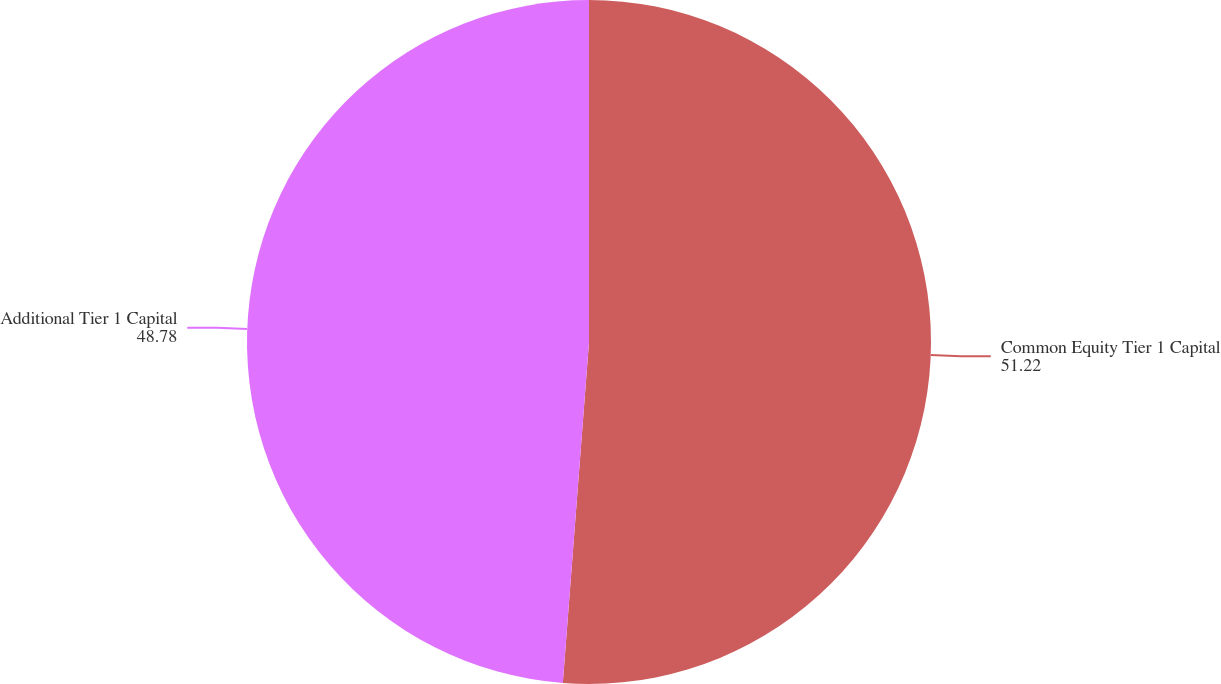Convert chart to OTSL. <chart><loc_0><loc_0><loc_500><loc_500><pie_chart><fcel>Common Equity Tier 1 Capital<fcel>Additional Tier 1 Capital<nl><fcel>51.22%<fcel>48.78%<nl></chart> 